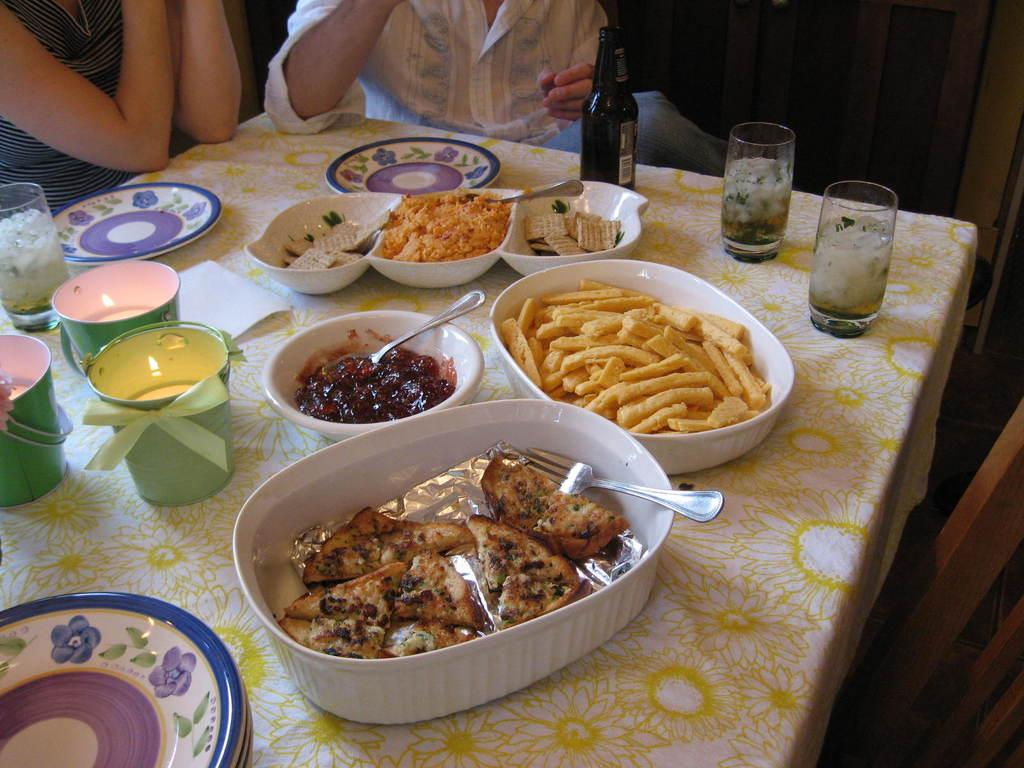How many people are in front of the table in the image? There are persons in front of the table in the image. What items can be seen on the table? The table contains glasses, plates, cups, a bottle, and bowls. What might be used for drinking in the image? Glasses and cups on the table might be used for drinking. What might be used for holding liquids in the image? The bottle on the table might be used for holding liquids. What type of string is being used by the governor in the image? There is no governor or string present in the image. How many boys are sitting at the table in the image? There is no mention of boys in the image; it only mentions persons in front of the table. 